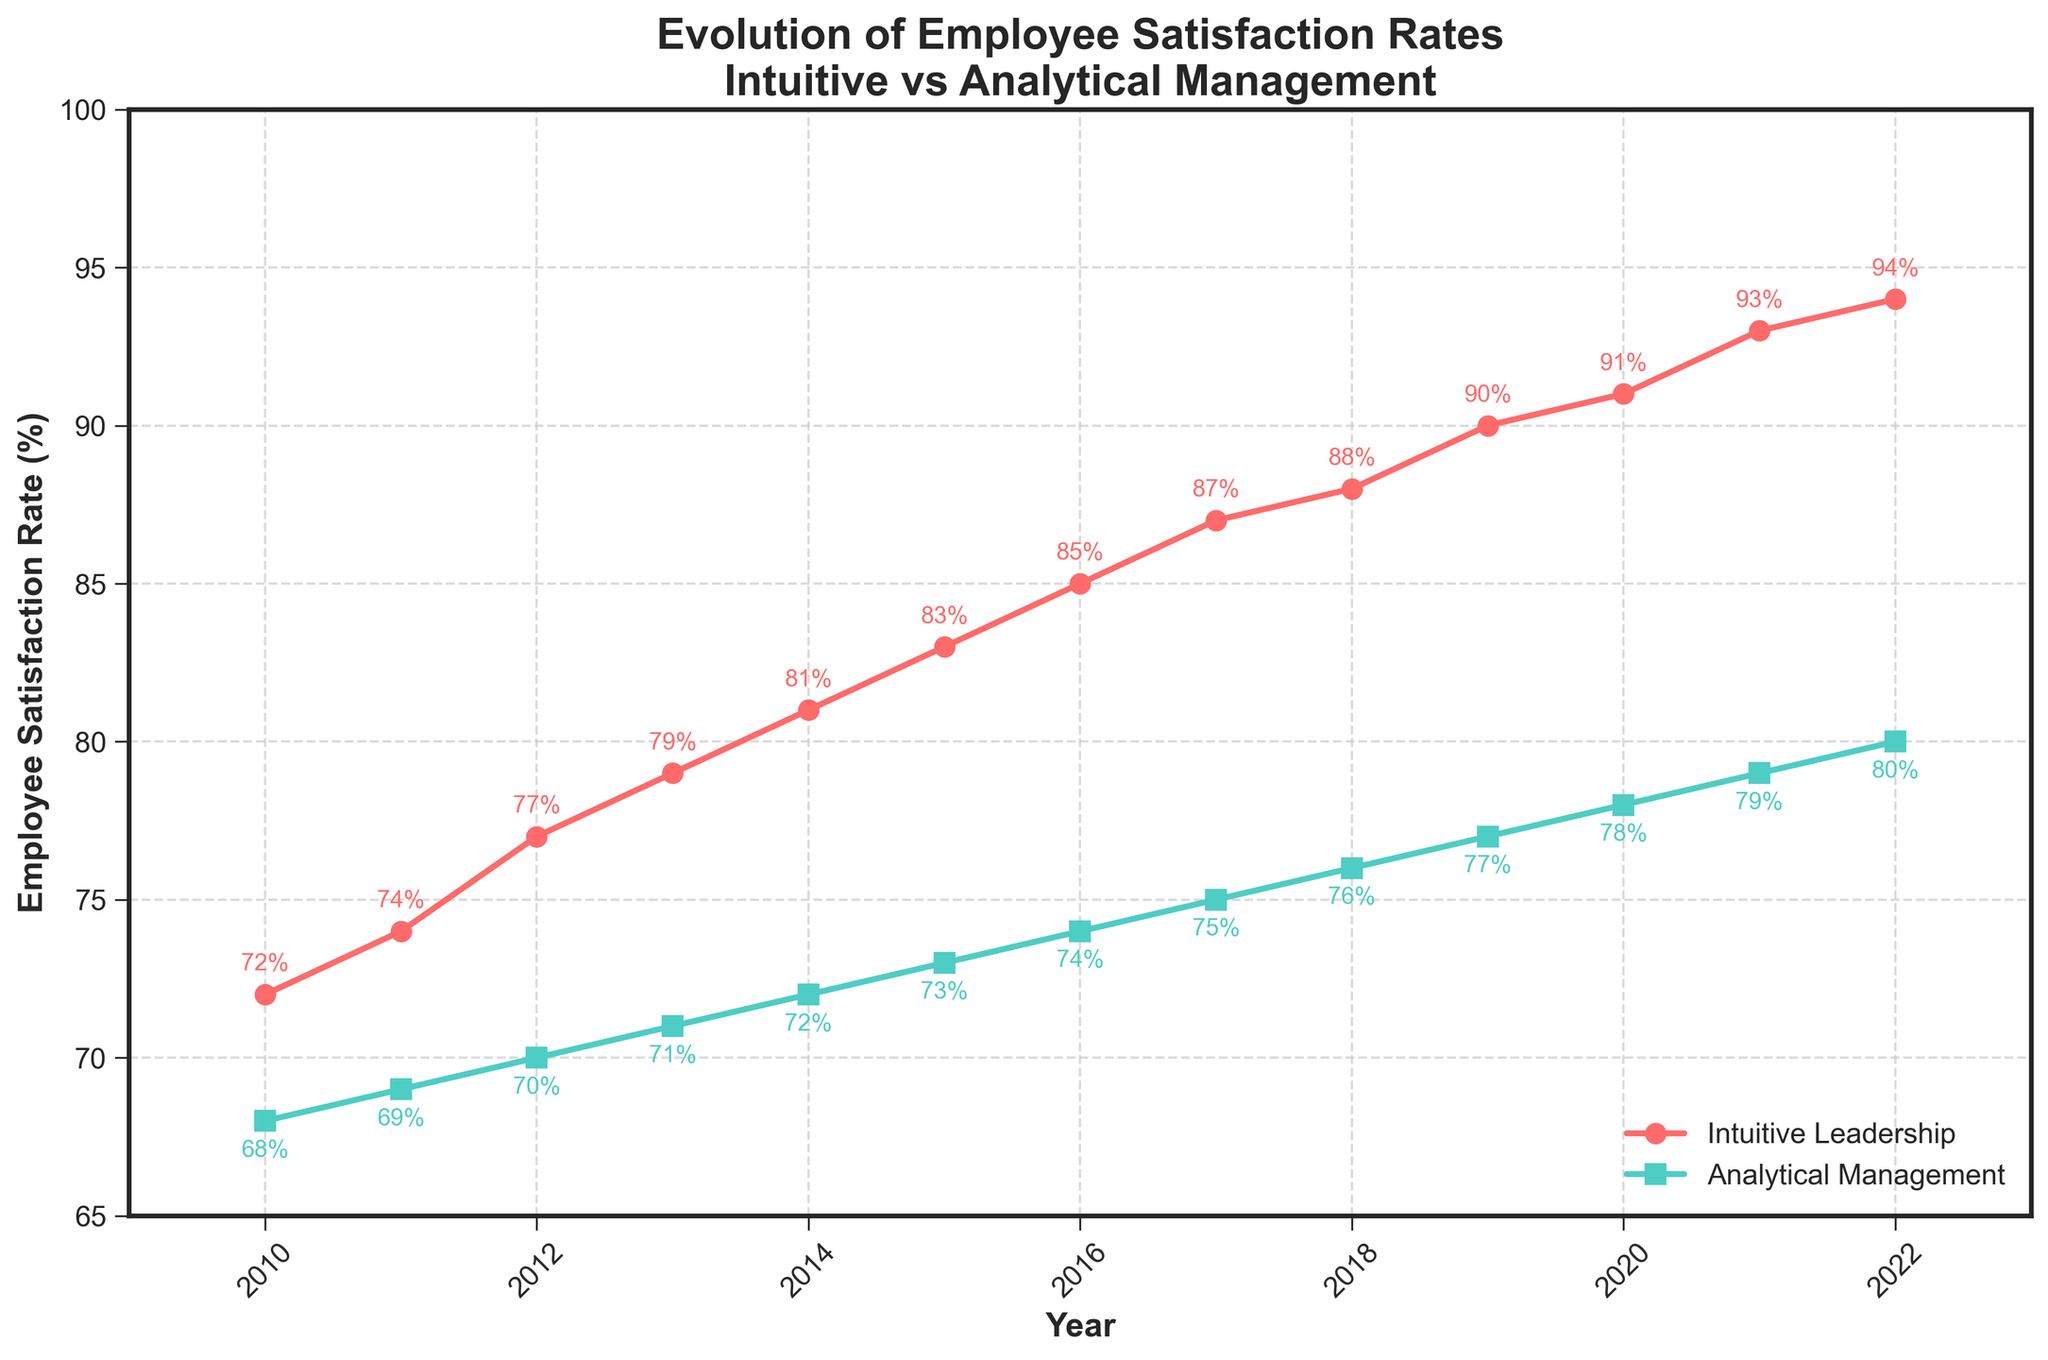What's the rate of employee satisfaction in intuitive leadership companies in 2015? Look at the red line on the chart for intuitive leadership companies and locate the year 2015. The data label indicates 83%.
Answer: 83% How does the rate of employee satisfaction in analytical management companies change from 2012 to 2015? Observe the green line for analytical management companies and find the points for 2012 and 2015. In 2012, the rate is 70%, and in 2015, it's 73%. The change is 73% - 70% = 3%.
Answer: Increased by 3% Which type of leadership shows a higher employee satisfaction rate in 2020? Compare the satisfaction rates in 2020 by looking at the end points of both lines. The red line (intuitive) shows 91%, and the green line (analytical) shows 78%.
Answer: Intuitive leadership In which year do intuitive leadership companies reach an employee satisfaction rate of 90%? Follow the red line indicating intuitive leadership until it reaches 90%. This occurs in 2019.
Answer: 2019 By how much did the employee satisfaction rate increase for intuitive leadership companies from 2010 to 2022? For intuitive leadership companies, in 2010, the rate is 72%, and in 2022, it's 94%. The increase is 94% - 72% = 22%.
Answer: 22% What is the difference in employee satisfaction rates between the two types of leadership in 2013? Check the values for 2013: intuitive leadership is 79%, and analytical management is 71%. The difference is 79% - 71% = 8%.
Answer: 8% In terms of employee satisfaction, which year shows the smallest gap between the two types of leadership? Calculate the gaps for each year by subtracting the analytical line value from the intuitive line value. The smallest gap is 4 in 2010 (72% - 68% = 4).
Answer: 2010 What trend can be observed for both leadership types from 2010 to 2022? Both lines (red for intuitive and green for analytical) show an upward trend from 2010 to 2022, indicating an increase in employee satisfaction rates for both leadership types over the years.
Answer: Upward trend Calculate the average employee satisfaction rate for analytical management companies from 2016 to 2020. Add the values for the specified years and divide by the number of years: (74% + 75% + 76% + 77% + 78%) / 5 = 380% / 5 = 76%.
Answer: 76% In which year did intuitive leadership achieve a satisfaction rate that was 10% higher than analytical management? Identify the year where the gap between the two lines is 10%. In 2017, intuitive leadership is 87%, and analytical management is 75%, making the difference 87% - 75% = 12%. In 2016, intuitive leadership is 85%, and analytical management is 74%, making the difference 11%. Therefore, no exact year shows a 10% difference.
Answer: No exact year 